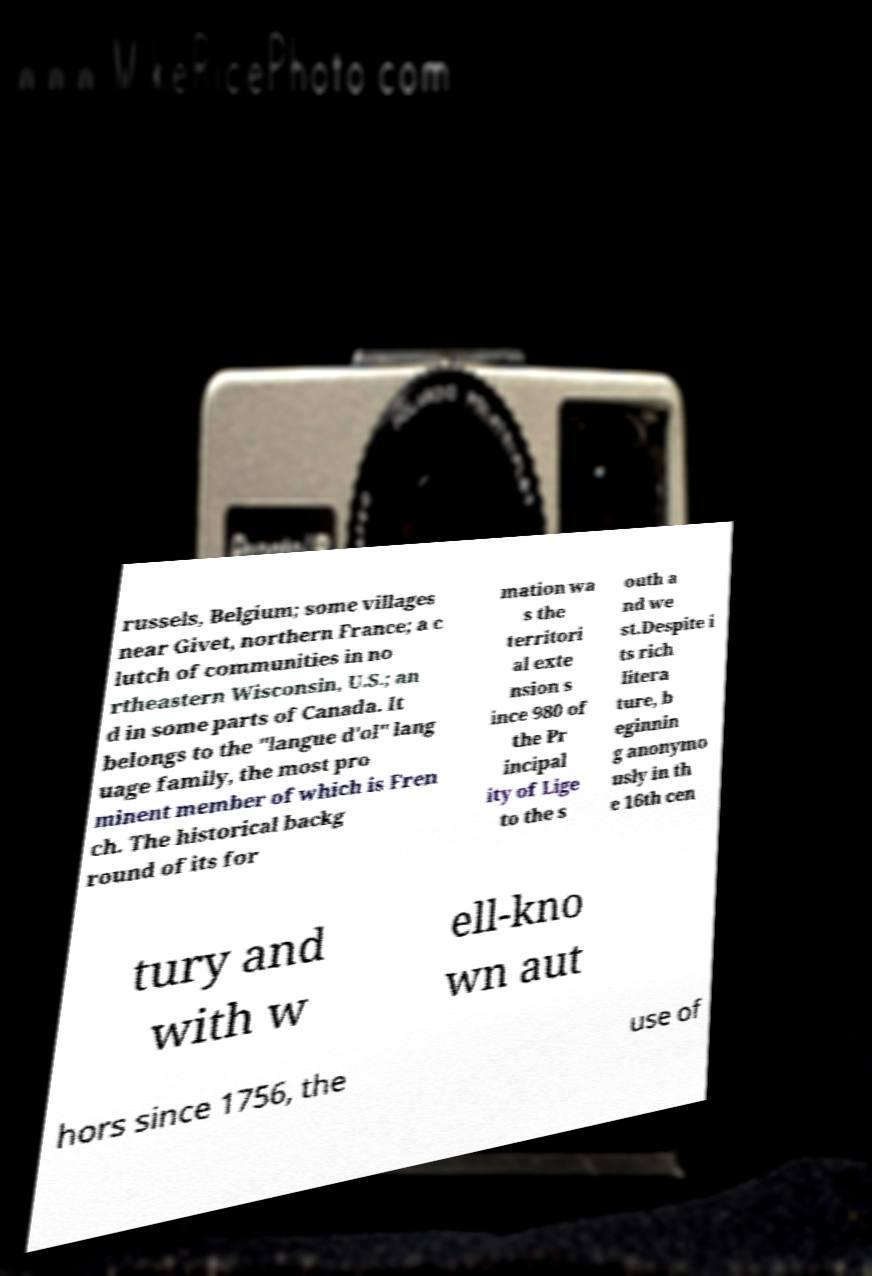Can you accurately transcribe the text from the provided image for me? russels, Belgium; some villages near Givet, northern France; a c lutch of communities in no rtheastern Wisconsin, U.S.; an d in some parts of Canada. It belongs to the "langue d'ol" lang uage family, the most pro minent member of which is Fren ch. The historical backg round of its for mation wa s the territori al exte nsion s ince 980 of the Pr incipal ity of Lige to the s outh a nd we st.Despite i ts rich litera ture, b eginnin g anonymo usly in th e 16th cen tury and with w ell-kno wn aut hors since 1756, the use of 